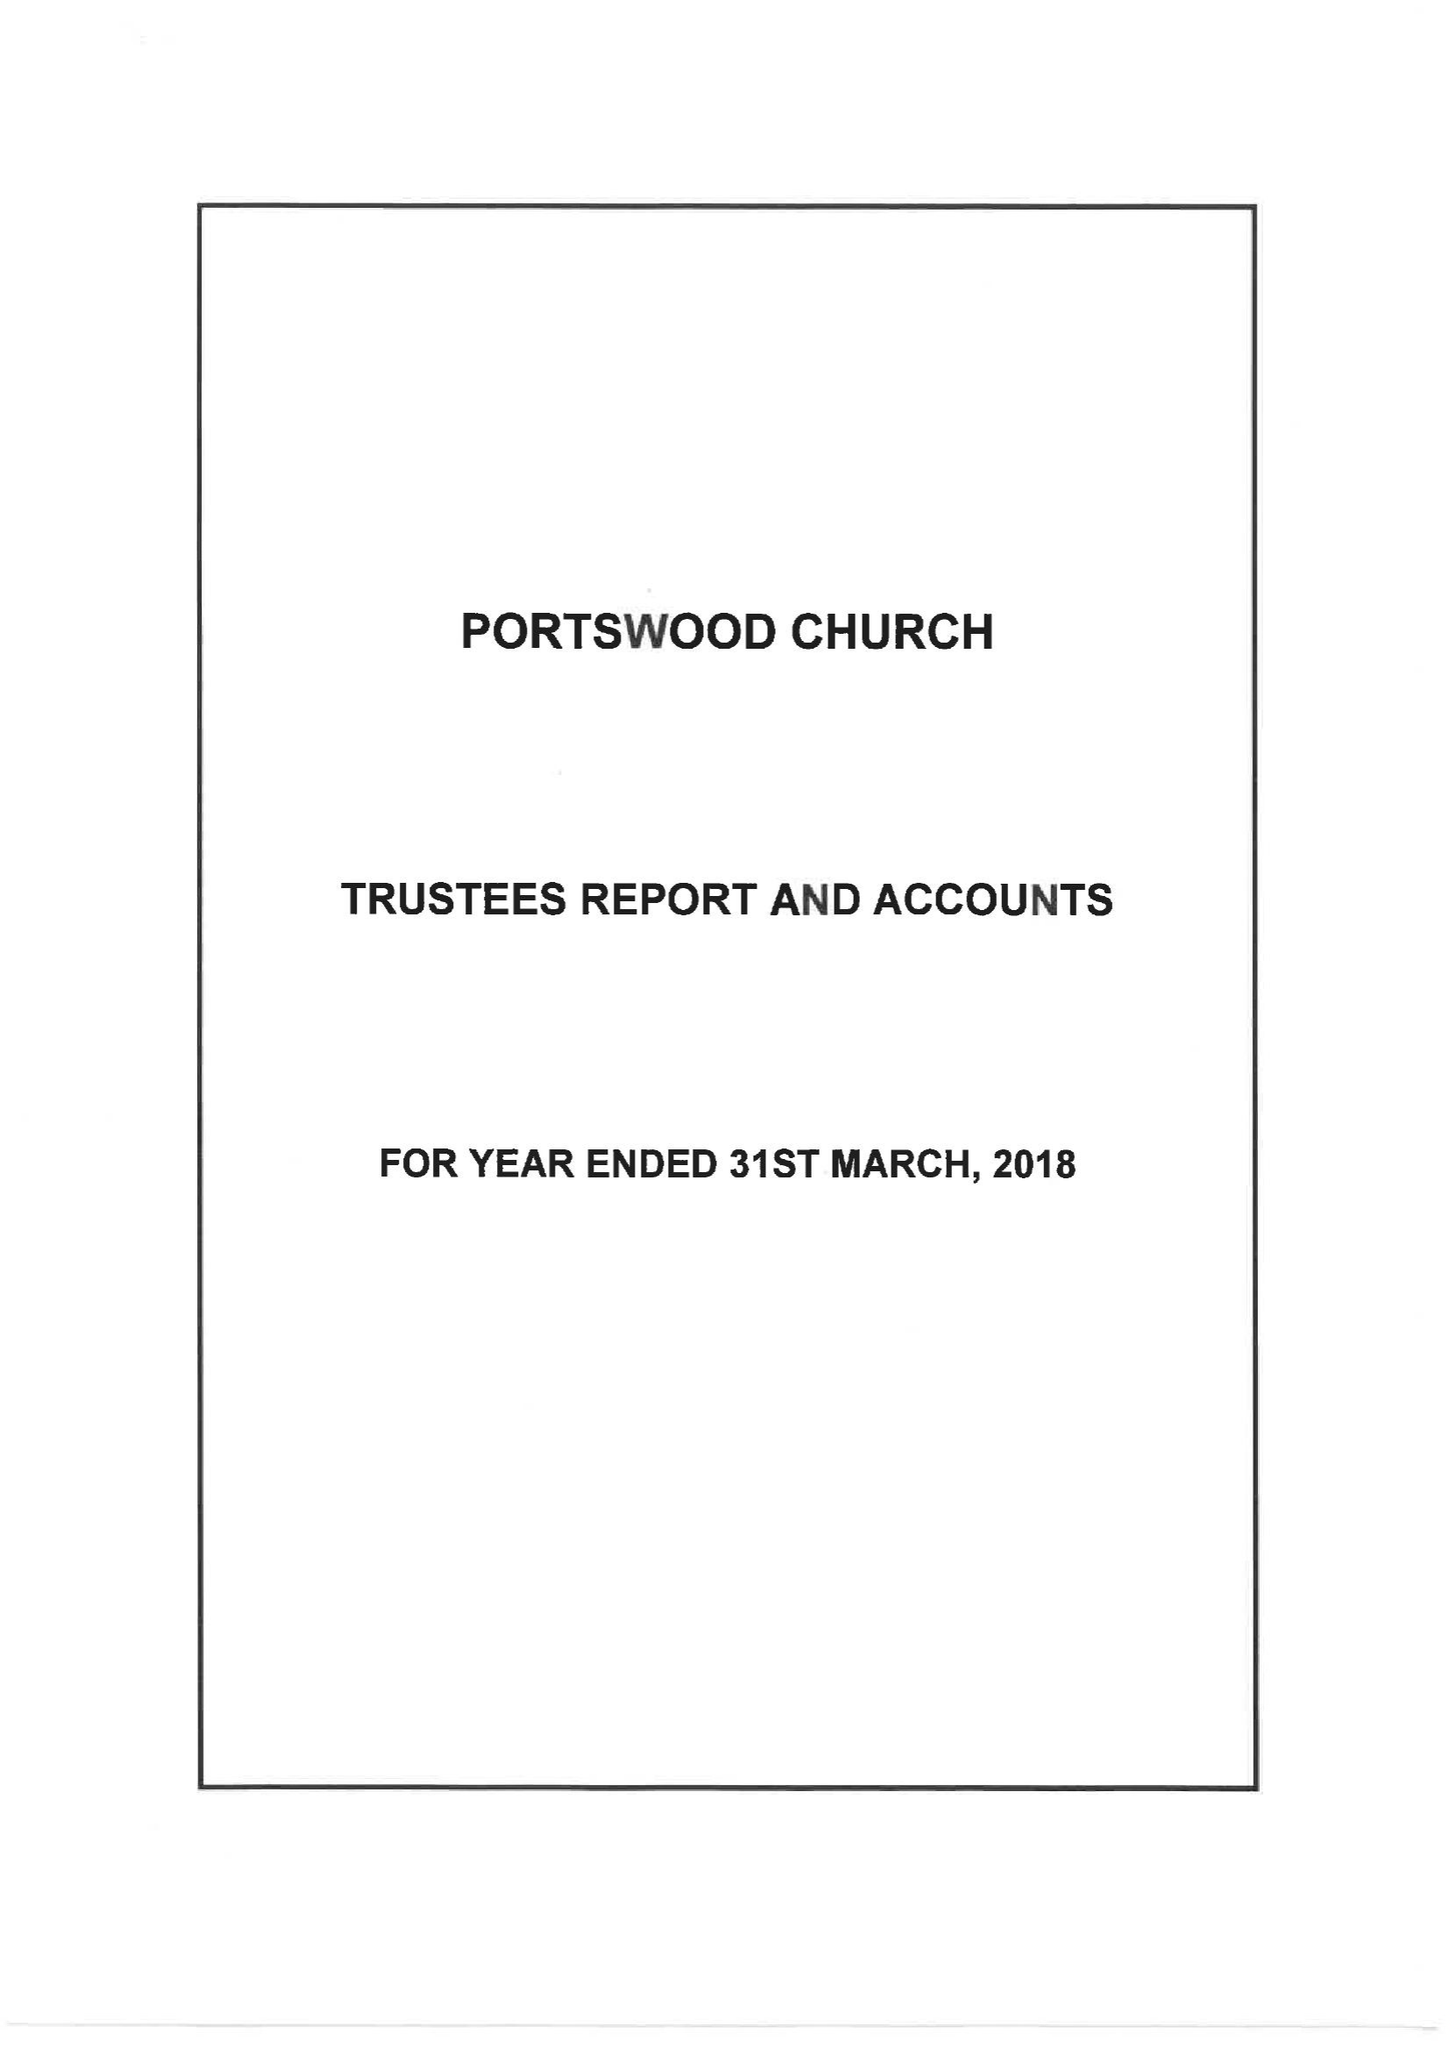What is the value for the address__postcode?
Answer the question using a single word or phrase. SO17 2FY 